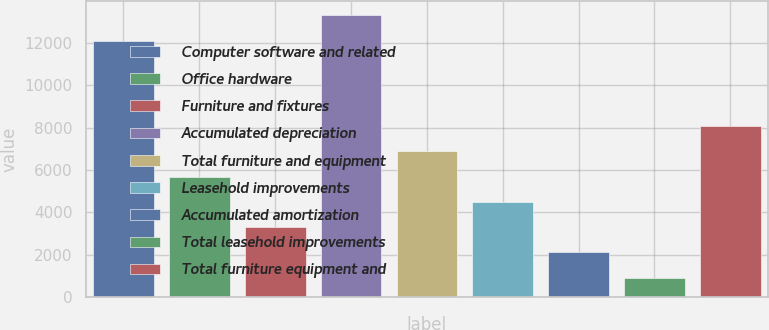Convert chart. <chart><loc_0><loc_0><loc_500><loc_500><bar_chart><fcel>Computer software and related<fcel>Office hardware<fcel>Furniture and fixtures<fcel>Accumulated depreciation<fcel>Total furniture and equipment<fcel>Leasehold improvements<fcel>Accumulated amortization<fcel>Total leasehold improvements<fcel>Total furniture equipment and<nl><fcel>12099<fcel>5685.8<fcel>3300.4<fcel>13291.7<fcel>6878.5<fcel>4493.1<fcel>2107.7<fcel>915<fcel>8071.2<nl></chart> 